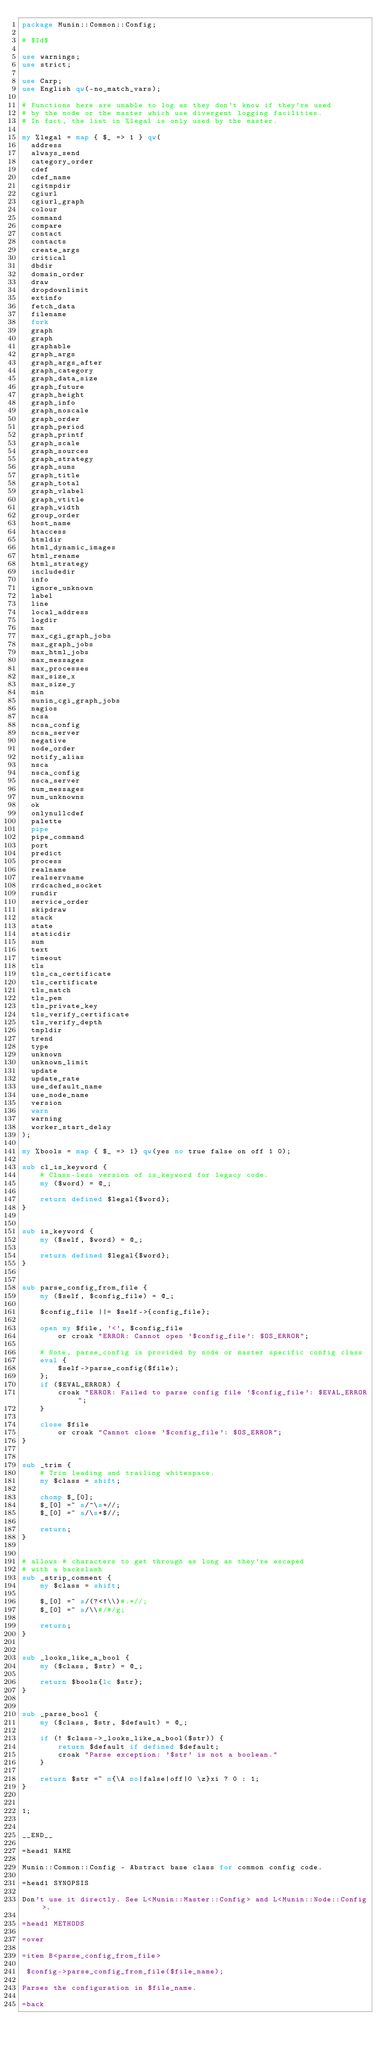Convert code to text. <code><loc_0><loc_0><loc_500><loc_500><_Perl_>package Munin::Common::Config;

# $Id$

use warnings;
use strict;

use Carp;
use English qw(-no_match_vars);

# Functions here are unable to log as they don't know if they're used
# by the node or the master which use divergent logging facilities.
# In fact, the list in %legal is only used by the master.

my %legal = map { $_ => 1 } qw(
	address
	always_send
	category_order
	cdef
	cdef_name
	cgitmpdir
	cgiurl
	cgiurl_graph
	colour
	command
	compare
	contact
	contacts
	create_args
	critical
	dbdir
	domain_order
	draw
	dropdownlimit
	extinfo
	fetch_data
	filename
	fork
	graph
	graph
	graphable
	graph_args
	graph_args_after
	graph_category
	graph_data_size
	graph_future
	graph_height
	graph_info
	graph_noscale
	graph_order
	graph_period
	graph_printf
	graph_scale
	graph_sources
	graph_strategy
	graph_sums
	graph_title
	graph_total
	graph_vlabel
	graph_vtitle
	graph_width
	group_order
	host_name
	htaccess
	htmldir
	html_dynamic_images
	html_rename
	html_strategy
	includedir
	info
	ignore_unknown
	label
	line
	local_address
	logdir
	max
	max_cgi_graph_jobs
	max_graph_jobs
	max_html_jobs
	max_messages
	max_processes
	max_size_x
	max_size_y
	min
	munin_cgi_graph_jobs
	nagios
	ncsa
	ncsa_config
	ncsa_server
	negative
	node_order
	notify_alias
	nsca
	nsca_config
	nsca_server
	num_messages
	num_unknowns
	ok
	onlynullcdef
	palette
	pipe
	pipe_command
	port
	predict
	process
	realname
	realservname
	rrdcached_socket
	rundir
	service_order
	skipdraw
	stack
	state
	staticdir
	sum
	text
	timeout
	tls
	tls_ca_certificate
	tls_certificate
	tls_match
	tls_pem
	tls_private_key
	tls_verify_certificate
	tls_verify_depth
	tmpldir
	trend
	type
	unknown
	unknown_limit
	update
	update_rate
	use_default_name
	use_node_name
	version
	warn
	warning
	worker_start_delay
);

my %bools = map { $_ => 1} qw(yes no true false on off 1 0);

sub cl_is_keyword {
    # Class-less version of is_keyword for legacy code.
    my ($word) = @_;

    return defined $legal{$word};
}


sub is_keyword {
    my ($self, $word) = @_;

    return defined $legal{$word};
}


sub parse_config_from_file {
    my ($self, $config_file) = @_;

    $config_file ||= $self->{config_file};

    open my $file, '<', $config_file
        or croak "ERROR: Cannot open '$config_file': $OS_ERROR";

    # Note, parse_config is provided by node or master specific config class
    eval {
        $self->parse_config($file);
    };
    if ($EVAL_ERROR) {
        croak "ERROR: Failed to parse config file '$config_file': $EVAL_ERROR";
    }

    close $file
        or croak "Cannot close '$config_file': $OS_ERROR";
}


sub _trim {
    # Trim leading and trailing whitespace.
    my $class = shift;

    chomp $_[0];
    $_[0] =~ s/^\s+//;
    $_[0] =~ s/\s+$//;

    return;
}


# allows # characters to get through as long as they're escaped
# with a backslash
sub _strip_comment {
    my $class = shift;

    $_[0] =~ s/(?<!\\)#.*//;
    $_[0] =~ s/\\#/#/g;

    return;
}


sub _looks_like_a_bool {
    my ($class, $str) = @_;

    return $bools{lc $str};
}


sub _parse_bool {
    my ($class, $str, $default) = @_;

    if (! $class->_looks_like_a_bool($str)) {
        return $default if defined $default;
        croak "Parse exception: '$str' is not a boolean."
    }

    return $str =~ m{\A no|false|off|0 \z}xi ? 0 : 1;
}


1;


__END__

=head1 NAME

Munin::Common::Config - Abstract base class for common config code.

=head1 SYNOPSIS

Don't use it directly. See L<Munin::Master::Config> and L<Munin::Node::Config>.

=head1 METHODS

=over

=item B<parse_config_from_file>

 $config->parse_config_from_file($file_name);

Parses the configuration in $file_name.

=back
</code> 